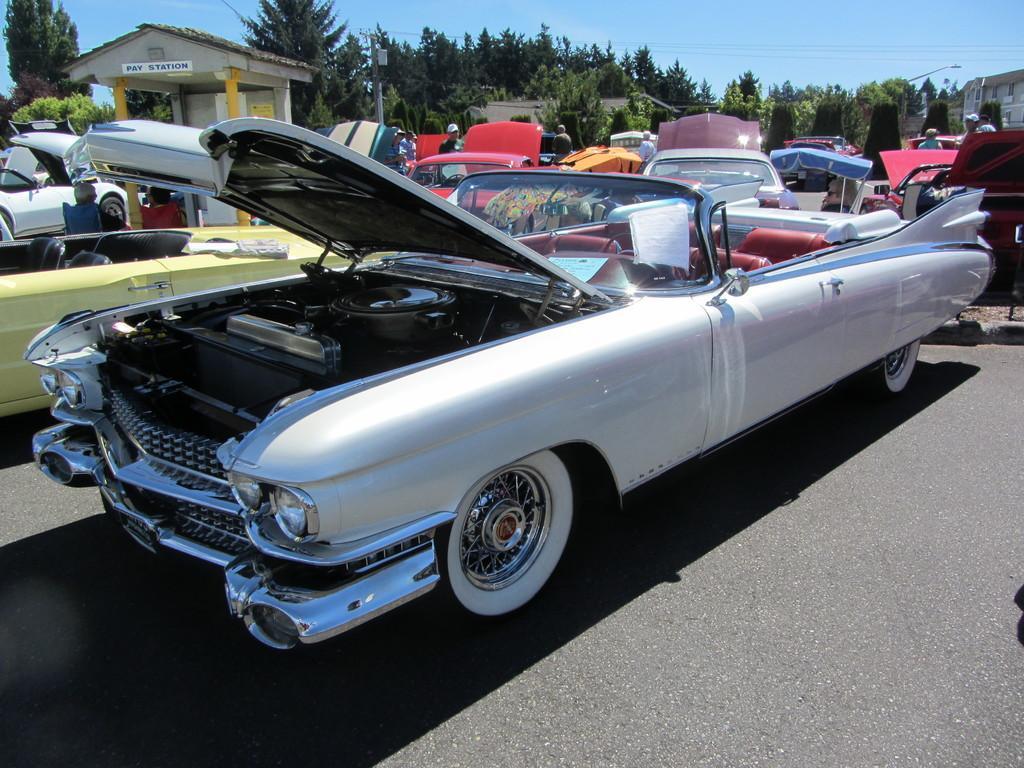Please provide a concise description of this image. In the image there are many cars in the foreground, behind the cars there is a playstation and around the paystation there are a lot of trees. 